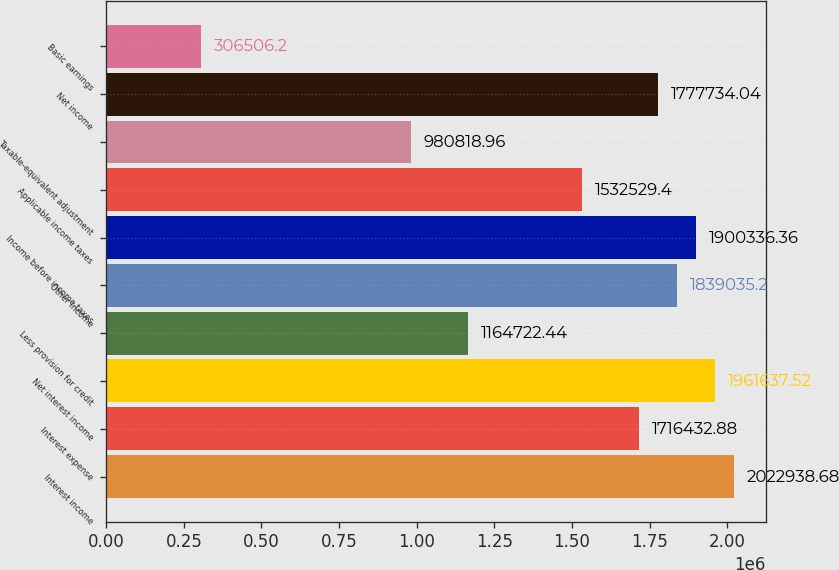Convert chart. <chart><loc_0><loc_0><loc_500><loc_500><bar_chart><fcel>Interest income<fcel>Interest expense<fcel>Net interest income<fcel>Less provision for credit<fcel>Other income<fcel>Income before income taxes<fcel>Applicable income taxes<fcel>Taxable-equivalent adjustment<fcel>Net income<fcel>Basic earnings<nl><fcel>2.02294e+06<fcel>1.71643e+06<fcel>1.96164e+06<fcel>1.16472e+06<fcel>1.83904e+06<fcel>1.90034e+06<fcel>1.53253e+06<fcel>980819<fcel>1.77773e+06<fcel>306506<nl></chart> 